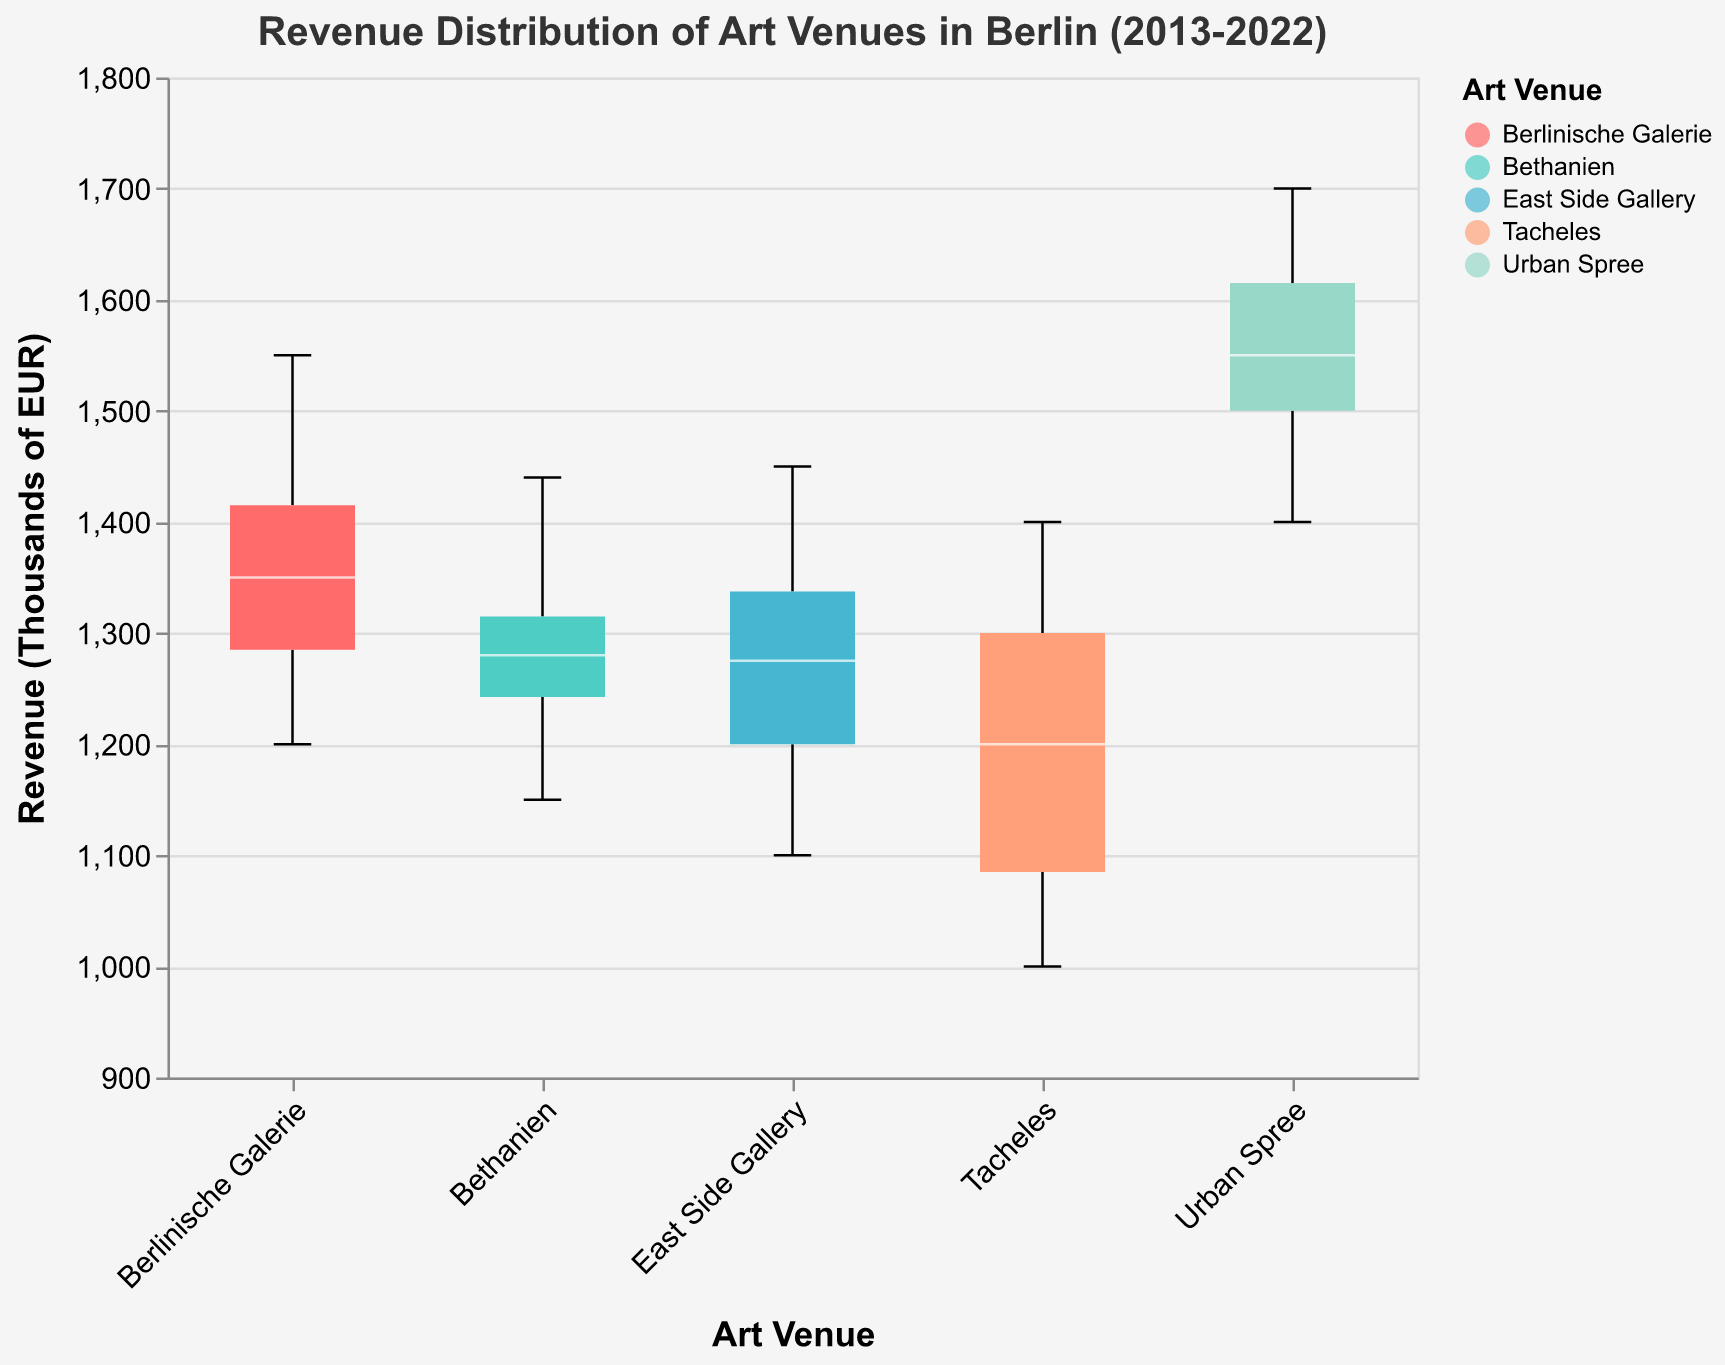What's the title of the figure? The title is located at the top of the figure. By reading it, we can see it states "Revenue Distribution of Art Venues in Berlin (2013-2022)."
Answer: Revenue Distribution of Art Venues in Berlin (2013-2022) What venue shows the highest median revenue? To find the highest median, we look at the middle line in each box. Urban Spree has the highest median revenue.
Answer: Urban Spree What's the revenue range for Tacheles? The range can be determined by finding the minimum and maximum data points for Tacheles. The range is from 1000 to 1400 thousands of EUR.
Answer: 1000 to 1400 Which venue has the smallest interquartile range (IQR)? The IQR is the range of the box excluding the tails and median. Bethanien has the smallest IQR as its box is the most compressed.
Answer: Bethanien How does the revenue of Berlinische Galerie in 2020 compare to its median revenue? The median revenue of Berlinische Galerie can be found as the line within its box, which seems higher than the 2020 revenue point.
Answer: The 2020 revenue is lower than the median What is the shape of the data distribution for the East Side Gallery? The shape of the data can be inferred by the boxplot's tails and the notched section. East Side Gallery shows an almost symmetrical box with equal-length whiskers.
Answer: Almost symmetrical Which art venue shows the highest variability in revenue over the decade? Highest variability can be identified by the length of the box and whiskers combined. Urban Spree shows the highest variability as its boxplot extends over the widest range.
Answer: Urban Spree Comparing Berlinische Galerie and East Side Gallery, which has a higher upper quartile? The upper quartile is the top of the box. Berlinische Galerie has a higher upper quartile compared to East Side Gallery.
Answer: Berlinische Galerie Is the revenue of Urban Spree skewed in any way? By observing the boxplot's shape and whiskers, we notice the longer tail towards higher values. This indicates a positive skew.
Answer: Positively skewed Which venue has the least difference between its median and maximum revenue? By looking closely at the median (line within the box) and the maximum point (top whisker) for each venue, East Side Gallery has the least difference.
Answer: East Side Gallery 